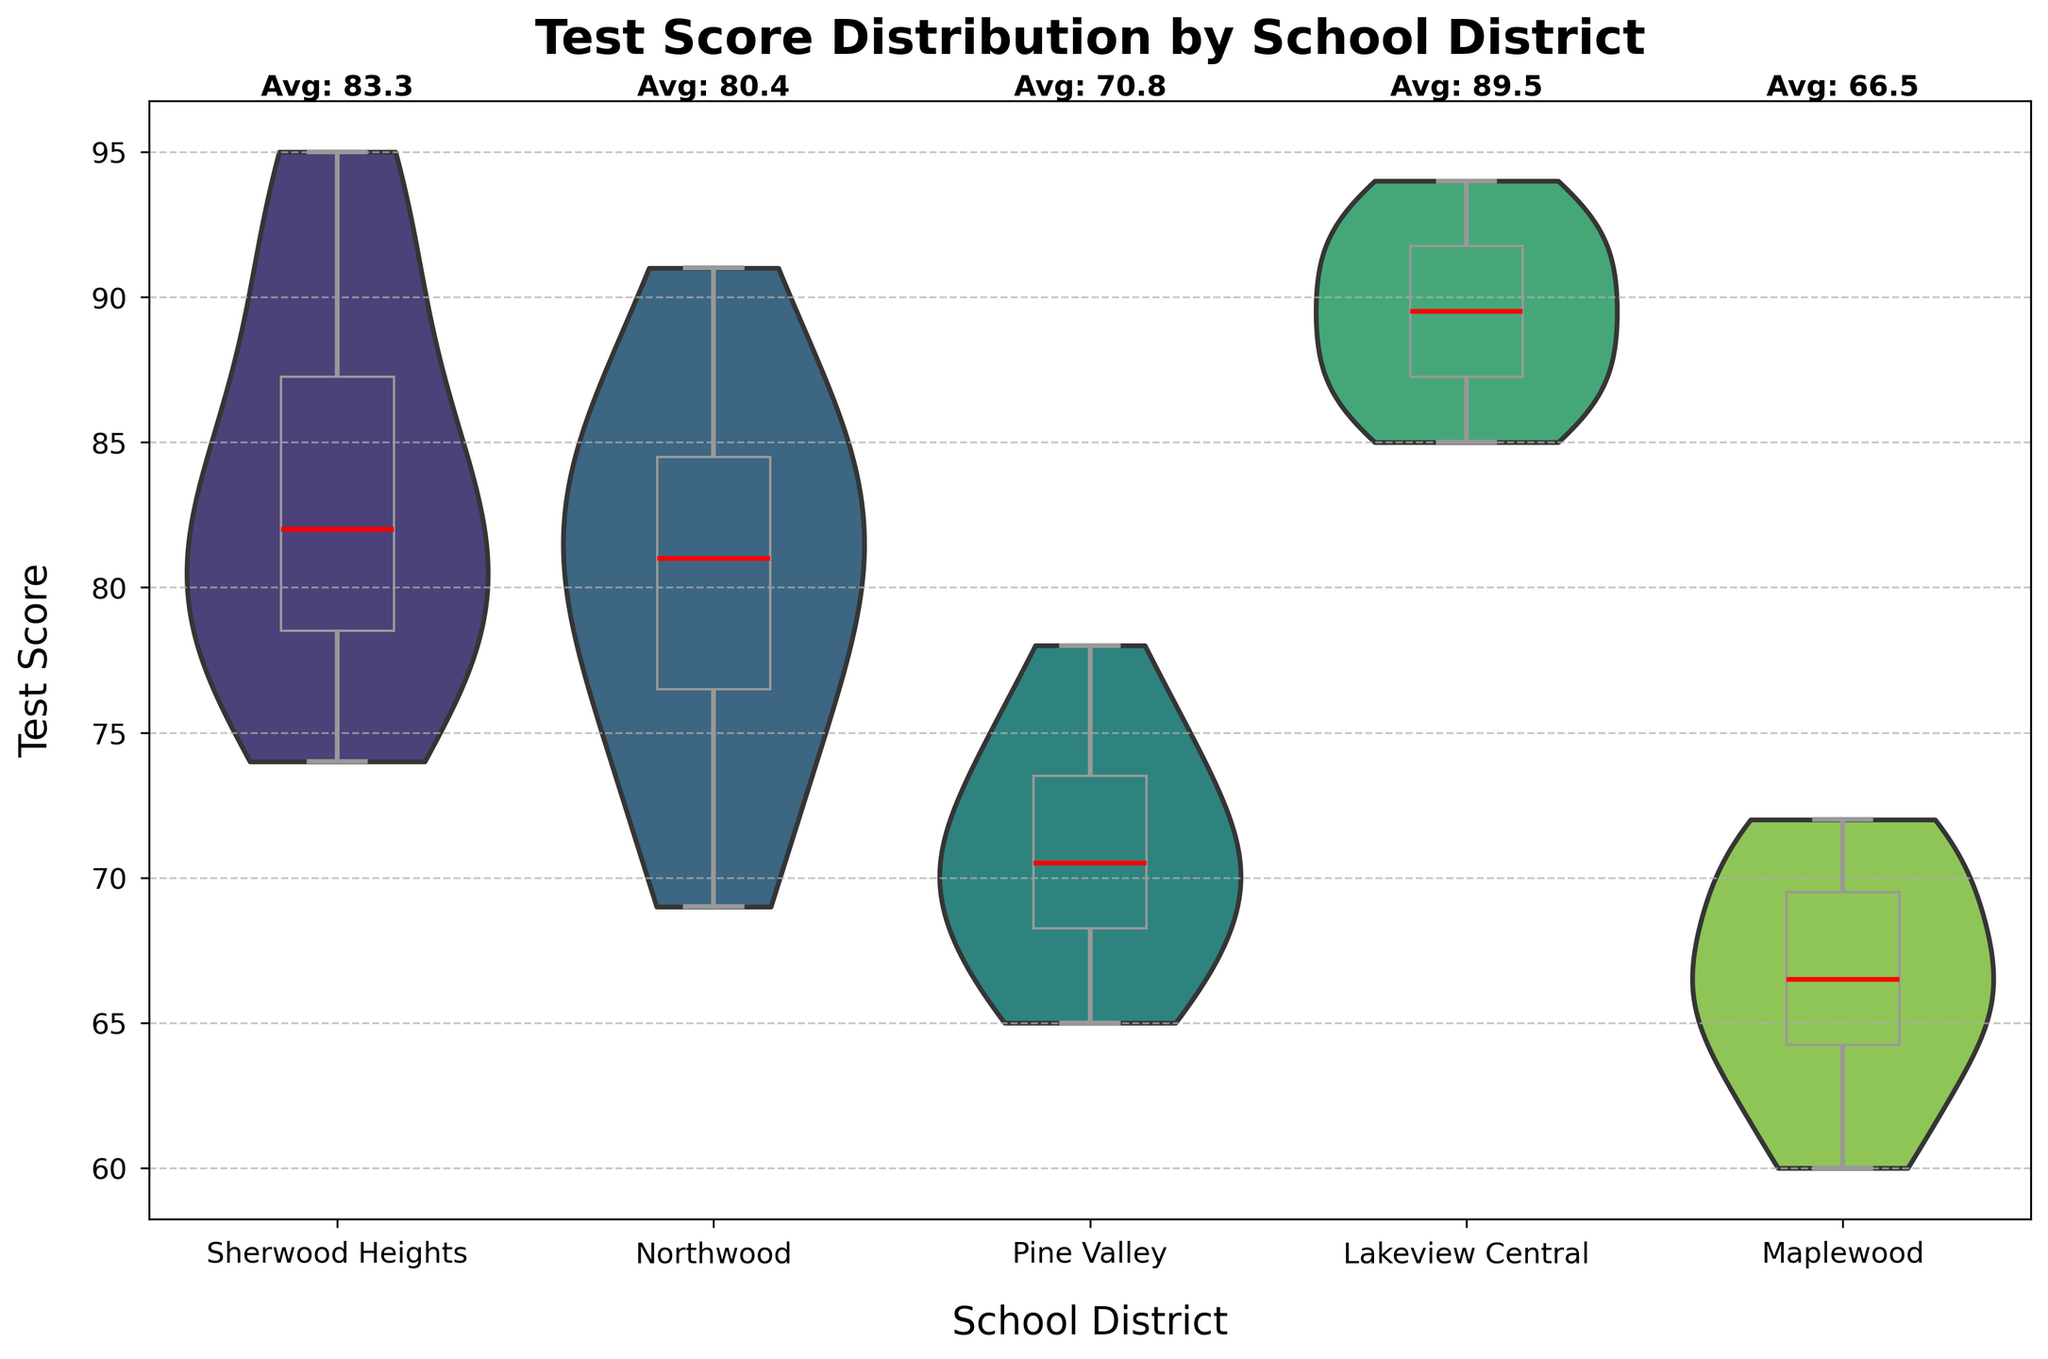What is the title of the figure? The title can be found at the top of the figure. It usually provides a brief summary of what the plot represents.
Answer: Test Score Distribution by School District Which school district has the highest median test score? The median is represented by the red line inside the box plot. By inspecting the median lines across all districts, the district with the highest median can be identified.
Answer: Lakeview Central What is the average test score for Sherwood Heights? The average score for Sherwood Heights is displayed above the violin plot for the district.
Answer: 83.3 Which school district has the widest range of test scores? The range can be observed from the whiskers of the box plot within each violin plot, representing the minimum and maximum values. The district with the longest whiskers has the widest range.
Answer: Lakeview Central How do the test scores for Northwood compare to those of Pine Valley? Compare the distribution shapes and medians (red lines) of the box plots within the violin plots of Northwood and Pine Valley. Northwood's scores are more dispersed and generally higher, with a higher median compared to Pine Valley.
Answer: Northwood has generally higher and more dispersed scores than Pine Valley Which district shows the smallest interquartile range (IQR)? The IQR is the range between the 25th percentile (bottom of the box) and the 75th percentile (top of the box). The district with the smallest box has the smallest IQR.
Answer: Lakeview Central What is the average score difference between Sherwood Heights and Maplewood? Subtract the average score of Maplewood from the average score of Sherwood Heights. These average scores are labeled above each district's violin plot.
Answer: 83.3 - 66.5 = 16.8 Are there any outliers in the test scores for Maplewood? Outliers are represented by red dots outside the whiskers of the box plot. Check the Maplewood plot for any such dots.
Answer: No Which school district has the lowest average test score? The average score for each district is labeled above the violin plot. Identify the district with the lowest labeled average score.
Answer: Maplewood How do the variances in test scores differ across the districts? Variance can be inferred from the width and spread of the violin plots. A wider, more spread-out plot indicates higher variance. Compare the shapes of the violin plots across the districts to understand the differences in variance.
Answer: Pine Valley shows a high variance, while Sherwood Heights shows lower variance 